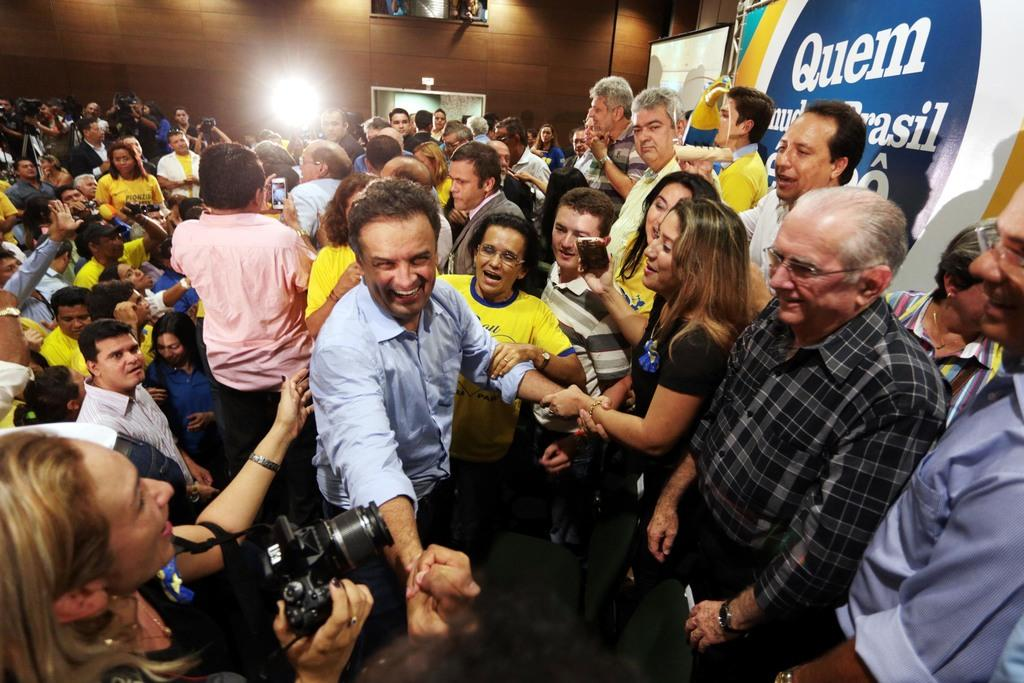What are the people in the image doing? There are people standing in the image, and some of them are holding cameras in their hands. Can you describe the expressions on the faces of the people in the image? Some people are smiling in the image. What type of oatmeal is being served at the event in the image? There is no mention of oatmeal or an event in the image; it simply shows people standing and holding cameras. 